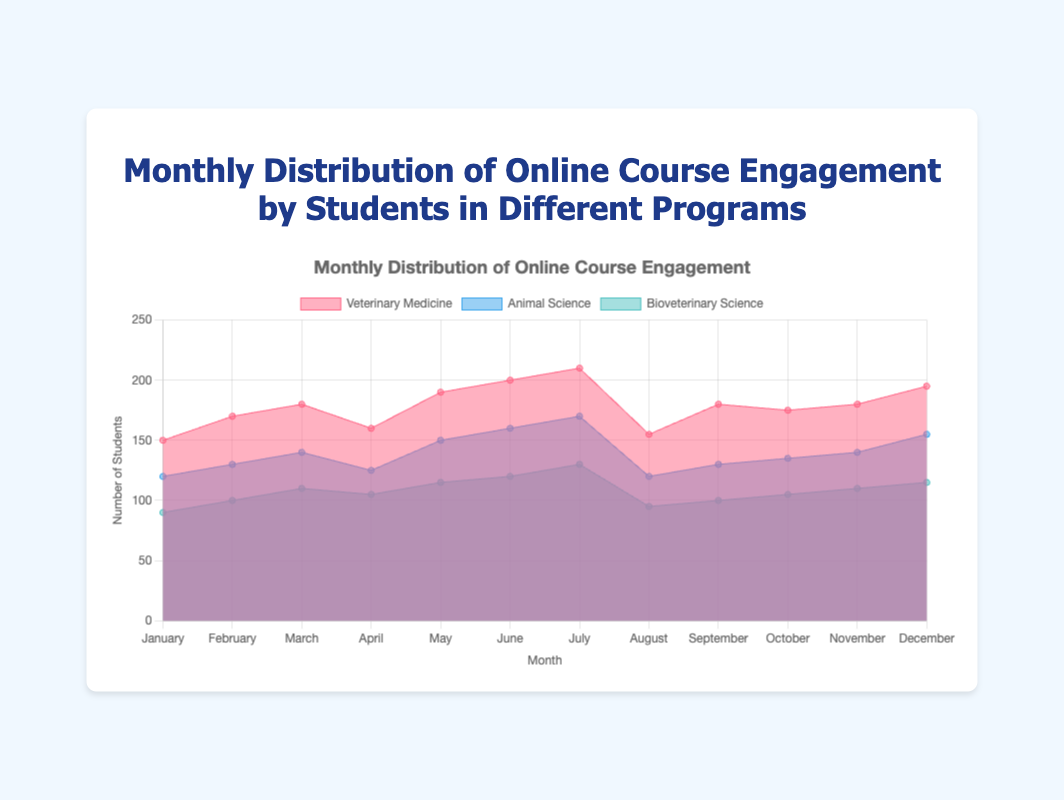What is the title of the chart? The title is usually at the top of the chart and provides a summary of what the chart represents. In this case, it is prominently displayed in the center.
Answer: Monthly Distribution of Online Course Engagement by Students in Different Programs Which program showed the highest engagement in July? By examining the chart, you can see that the Veterinary Medicine line is the highest in July, indicating the highest engagement.
Answer: Veterinary Medicine How does the engagement in Animal Science compare between June and July? Looking at the Animal Science line, it rises from June (160) to July (170), indicating an increase in engagement.
Answer: The engagement increased In which month did Bioveterinary Science engagement peak? By tracking the highest point of the Bioveterinary Science line on the chart, we see that August (130) was the month with the peak.
Answer: July Calculate the average monthly engagement for Veterinary Medicine over the year. Add the monthly values for Veterinary Medicine and divide by the number of months: (150+170+180+160+190+200+210+155+180+175+180+195) / 12 = 181.25
Answer: 181.25 Which month had the lowest engagement across all programs? By looking at the chart for the lowest point in all the colored areas combined, August stands out with the Veterinary Medicine, Animal Science, and Bioveterinary Science all having lower values.
Answer: August Compare the engagement trend of Veterinary Medicine and Animal Science in the first quarter of the year. The first quarter consists of January to March. Veterinary Medicine increases from 150 to 170 to 180, while Animal Science also increases from 120 to 130 to 140. Both programs show an increasing trend, but Veterinary Medicine rises more sharply.
Answer: Both increased, Veterinary Medicine increased more sharply What is the total engagement for all programs in November? Add the engagement numbers across all programs in November: 180 (Veterinary Medicine) + 140 (Animal Science) + 110 (Bioveterinary Science) = 430.
Answer: 430 Is the engagement in Bioveterinary Science relatively stable or fluctuating throughout the year? By observing the Bioveterinary Science line, we see minor fluctuations but generally stable values between 90 and 130 over the months.
Answer: Relatively stable 